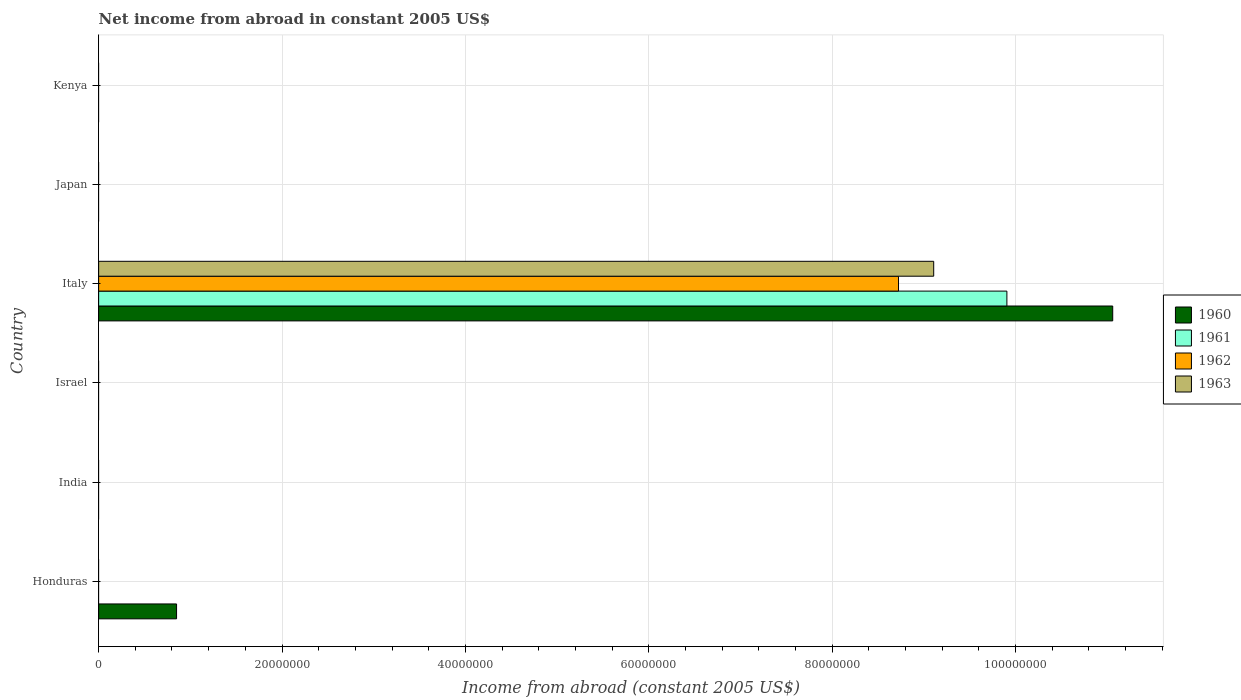How many different coloured bars are there?
Provide a succinct answer. 4. How many bars are there on the 2nd tick from the top?
Provide a short and direct response. 0. What is the label of the 5th group of bars from the top?
Ensure brevity in your answer.  India. Across all countries, what is the maximum net income from abroad in 1963?
Your response must be concise. 9.11e+07. Across all countries, what is the minimum net income from abroad in 1961?
Keep it short and to the point. 0. What is the total net income from abroad in 1962 in the graph?
Keep it short and to the point. 8.72e+07. What is the average net income from abroad in 1960 per country?
Your answer should be compact. 1.99e+07. What is the difference between the net income from abroad in 1963 and net income from abroad in 1962 in Italy?
Ensure brevity in your answer.  3.84e+06. In how many countries, is the net income from abroad in 1963 greater than 96000000 US$?
Your response must be concise. 0. What is the difference between the highest and the lowest net income from abroad in 1961?
Make the answer very short. 9.91e+07. In how many countries, is the net income from abroad in 1961 greater than the average net income from abroad in 1961 taken over all countries?
Your answer should be compact. 1. Is it the case that in every country, the sum of the net income from abroad in 1962 and net income from abroad in 1961 is greater than the sum of net income from abroad in 1960 and net income from abroad in 1963?
Offer a terse response. No. Is it the case that in every country, the sum of the net income from abroad in 1963 and net income from abroad in 1960 is greater than the net income from abroad in 1961?
Ensure brevity in your answer.  No. Are all the bars in the graph horizontal?
Offer a terse response. Yes. What is the difference between two consecutive major ticks on the X-axis?
Keep it short and to the point. 2.00e+07. Are the values on the major ticks of X-axis written in scientific E-notation?
Offer a very short reply. No. Does the graph contain any zero values?
Provide a succinct answer. Yes. Does the graph contain grids?
Make the answer very short. Yes. How many legend labels are there?
Ensure brevity in your answer.  4. How are the legend labels stacked?
Give a very brief answer. Vertical. What is the title of the graph?
Give a very brief answer. Net income from abroad in constant 2005 US$. Does "1991" appear as one of the legend labels in the graph?
Offer a terse response. No. What is the label or title of the X-axis?
Provide a short and direct response. Income from abroad (constant 2005 US$). What is the Income from abroad (constant 2005 US$) of 1960 in Honduras?
Your response must be concise. 8.50e+06. What is the Income from abroad (constant 2005 US$) in 1961 in Honduras?
Provide a short and direct response. 0. What is the Income from abroad (constant 2005 US$) in 1962 in Honduras?
Ensure brevity in your answer.  0. What is the Income from abroad (constant 2005 US$) in 1960 in India?
Give a very brief answer. 0. What is the Income from abroad (constant 2005 US$) of 1961 in India?
Your answer should be very brief. 0. What is the Income from abroad (constant 2005 US$) of 1962 in India?
Your answer should be compact. 0. What is the Income from abroad (constant 2005 US$) of 1963 in India?
Provide a succinct answer. 0. What is the Income from abroad (constant 2005 US$) in 1961 in Israel?
Your answer should be very brief. 0. What is the Income from abroad (constant 2005 US$) of 1963 in Israel?
Your answer should be compact. 0. What is the Income from abroad (constant 2005 US$) of 1960 in Italy?
Provide a succinct answer. 1.11e+08. What is the Income from abroad (constant 2005 US$) of 1961 in Italy?
Provide a short and direct response. 9.91e+07. What is the Income from abroad (constant 2005 US$) of 1962 in Italy?
Offer a very short reply. 8.72e+07. What is the Income from abroad (constant 2005 US$) in 1963 in Italy?
Give a very brief answer. 9.11e+07. What is the Income from abroad (constant 2005 US$) in 1962 in Japan?
Provide a short and direct response. 0. What is the Income from abroad (constant 2005 US$) in 1963 in Japan?
Keep it short and to the point. 0. What is the Income from abroad (constant 2005 US$) in 1960 in Kenya?
Make the answer very short. 0. What is the Income from abroad (constant 2005 US$) in 1961 in Kenya?
Ensure brevity in your answer.  0. What is the Income from abroad (constant 2005 US$) of 1962 in Kenya?
Ensure brevity in your answer.  0. What is the Income from abroad (constant 2005 US$) of 1963 in Kenya?
Your answer should be very brief. 0. Across all countries, what is the maximum Income from abroad (constant 2005 US$) in 1960?
Provide a succinct answer. 1.11e+08. Across all countries, what is the maximum Income from abroad (constant 2005 US$) in 1961?
Your answer should be compact. 9.91e+07. Across all countries, what is the maximum Income from abroad (constant 2005 US$) in 1962?
Provide a succinct answer. 8.72e+07. Across all countries, what is the maximum Income from abroad (constant 2005 US$) in 1963?
Ensure brevity in your answer.  9.11e+07. Across all countries, what is the minimum Income from abroad (constant 2005 US$) of 1961?
Ensure brevity in your answer.  0. Across all countries, what is the minimum Income from abroad (constant 2005 US$) of 1962?
Ensure brevity in your answer.  0. What is the total Income from abroad (constant 2005 US$) in 1960 in the graph?
Offer a very short reply. 1.19e+08. What is the total Income from abroad (constant 2005 US$) in 1961 in the graph?
Give a very brief answer. 9.91e+07. What is the total Income from abroad (constant 2005 US$) in 1962 in the graph?
Your response must be concise. 8.72e+07. What is the total Income from abroad (constant 2005 US$) in 1963 in the graph?
Your answer should be very brief. 9.11e+07. What is the difference between the Income from abroad (constant 2005 US$) in 1960 in Honduras and that in Italy?
Offer a very short reply. -1.02e+08. What is the difference between the Income from abroad (constant 2005 US$) of 1960 in Honduras and the Income from abroad (constant 2005 US$) of 1961 in Italy?
Offer a very short reply. -9.06e+07. What is the difference between the Income from abroad (constant 2005 US$) in 1960 in Honduras and the Income from abroad (constant 2005 US$) in 1962 in Italy?
Offer a terse response. -7.87e+07. What is the difference between the Income from abroad (constant 2005 US$) in 1960 in Honduras and the Income from abroad (constant 2005 US$) in 1963 in Italy?
Offer a very short reply. -8.26e+07. What is the average Income from abroad (constant 2005 US$) in 1960 per country?
Offer a terse response. 1.99e+07. What is the average Income from abroad (constant 2005 US$) in 1961 per country?
Provide a short and direct response. 1.65e+07. What is the average Income from abroad (constant 2005 US$) in 1962 per country?
Make the answer very short. 1.45e+07. What is the average Income from abroad (constant 2005 US$) of 1963 per country?
Offer a very short reply. 1.52e+07. What is the difference between the Income from abroad (constant 2005 US$) in 1960 and Income from abroad (constant 2005 US$) in 1961 in Italy?
Your answer should be very brief. 1.15e+07. What is the difference between the Income from abroad (constant 2005 US$) of 1960 and Income from abroad (constant 2005 US$) of 1962 in Italy?
Offer a terse response. 2.34e+07. What is the difference between the Income from abroad (constant 2005 US$) in 1960 and Income from abroad (constant 2005 US$) in 1963 in Italy?
Your answer should be very brief. 1.95e+07. What is the difference between the Income from abroad (constant 2005 US$) of 1961 and Income from abroad (constant 2005 US$) of 1962 in Italy?
Offer a very short reply. 1.18e+07. What is the difference between the Income from abroad (constant 2005 US$) of 1961 and Income from abroad (constant 2005 US$) of 1963 in Italy?
Your answer should be very brief. 7.98e+06. What is the difference between the Income from abroad (constant 2005 US$) in 1962 and Income from abroad (constant 2005 US$) in 1963 in Italy?
Your response must be concise. -3.84e+06. What is the ratio of the Income from abroad (constant 2005 US$) in 1960 in Honduras to that in Italy?
Provide a short and direct response. 0.08. What is the difference between the highest and the lowest Income from abroad (constant 2005 US$) of 1960?
Your response must be concise. 1.11e+08. What is the difference between the highest and the lowest Income from abroad (constant 2005 US$) in 1961?
Your answer should be compact. 9.91e+07. What is the difference between the highest and the lowest Income from abroad (constant 2005 US$) of 1962?
Keep it short and to the point. 8.72e+07. What is the difference between the highest and the lowest Income from abroad (constant 2005 US$) in 1963?
Your answer should be compact. 9.11e+07. 